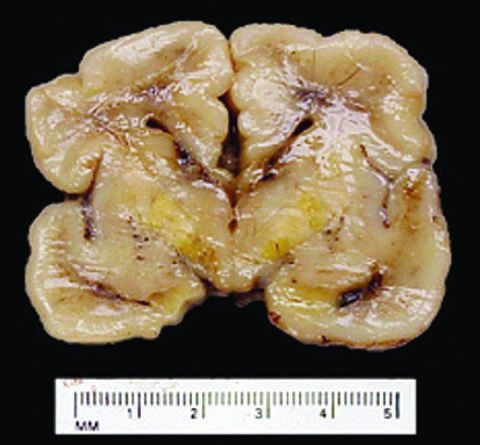s the blood-brain barrier less developed in the neonatal period than it is in adulthood?
Answer the question using a single word or phrase. Yes 